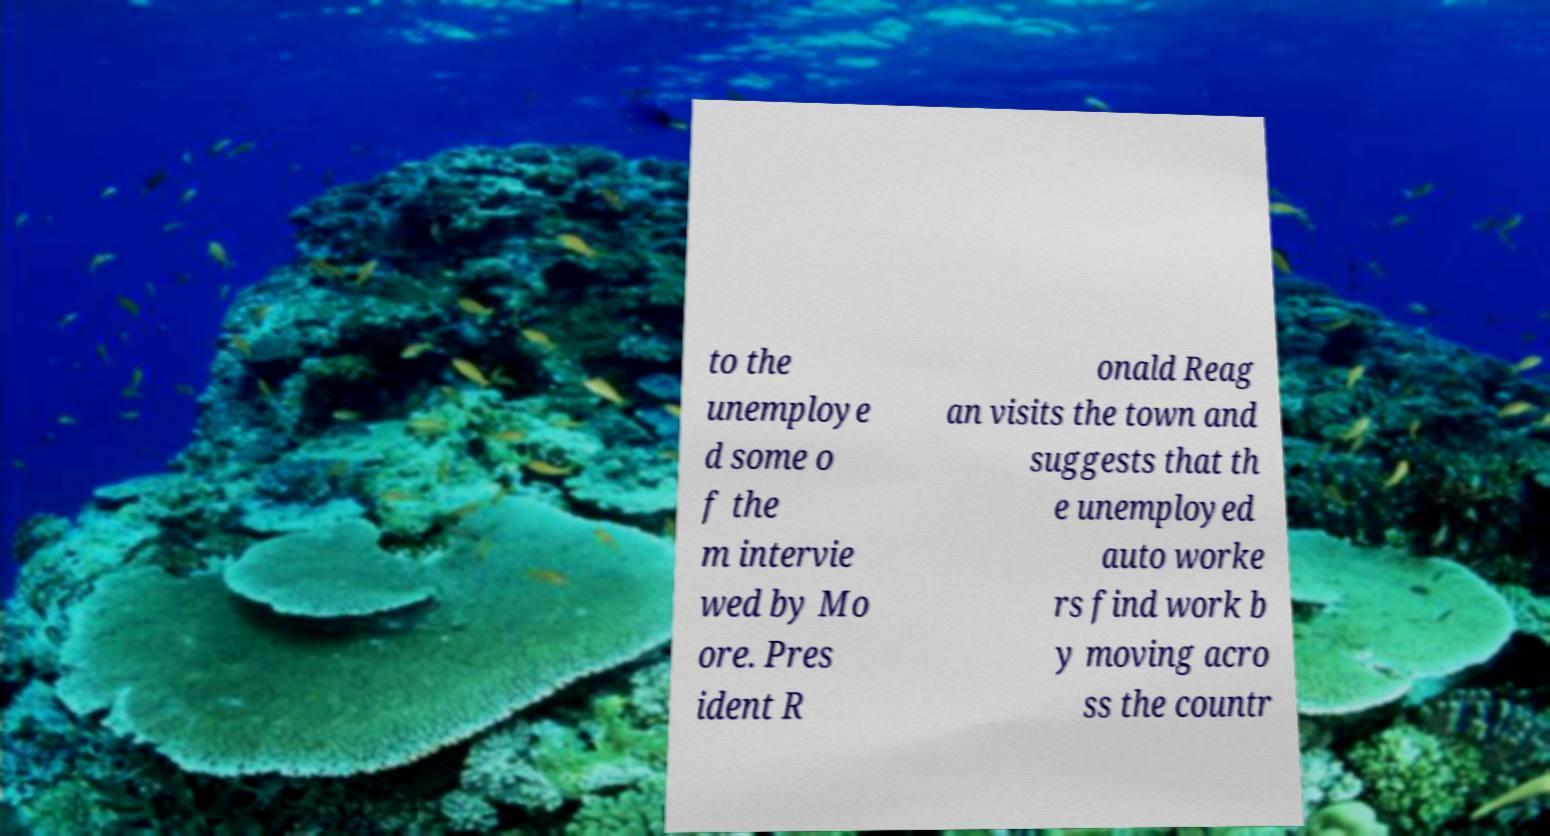Could you assist in decoding the text presented in this image and type it out clearly? to the unemploye d some o f the m intervie wed by Mo ore. Pres ident R onald Reag an visits the town and suggests that th e unemployed auto worke rs find work b y moving acro ss the countr 